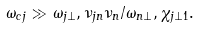<formula> <loc_0><loc_0><loc_500><loc_500>\omega _ { c j } \gg \omega _ { j \perp } , \nu _ { j n } \nu _ { n } / \omega _ { n \perp } , \chi _ { j \perp 1 } .</formula> 